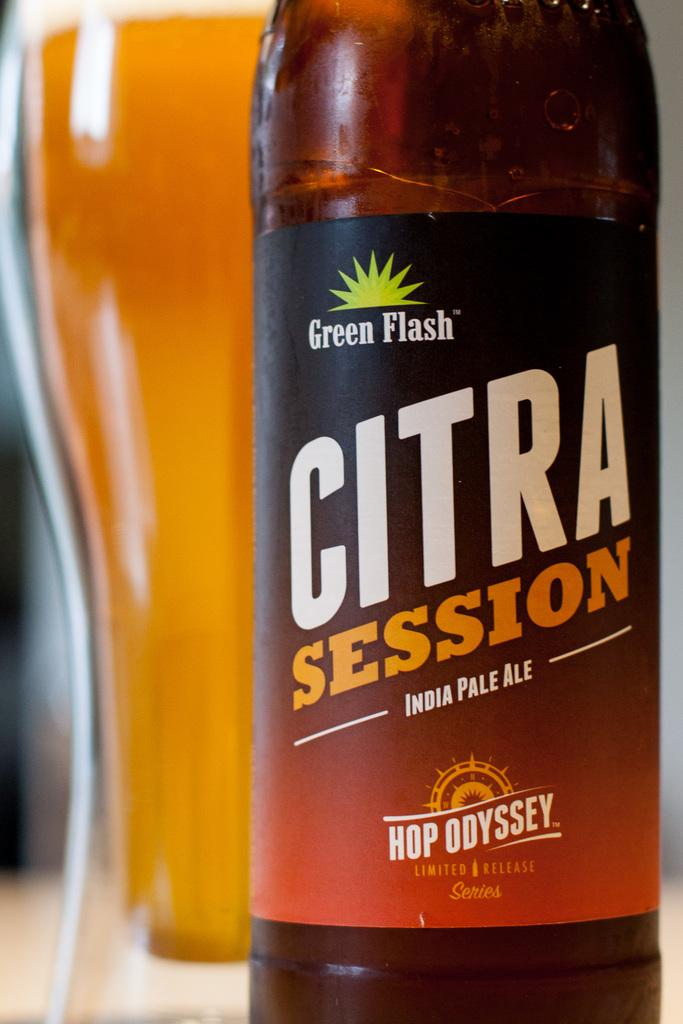What object is located in the foreground of the image? There is a bottle in the foreground of the image. What object is located behind the bottle? There is a glass behind the bottle. What type of wire is used to hold the plants in the image? There are no plants or wire present in the image. What type of linen is draped over the table in the image? There is no linen or table present in the image. 